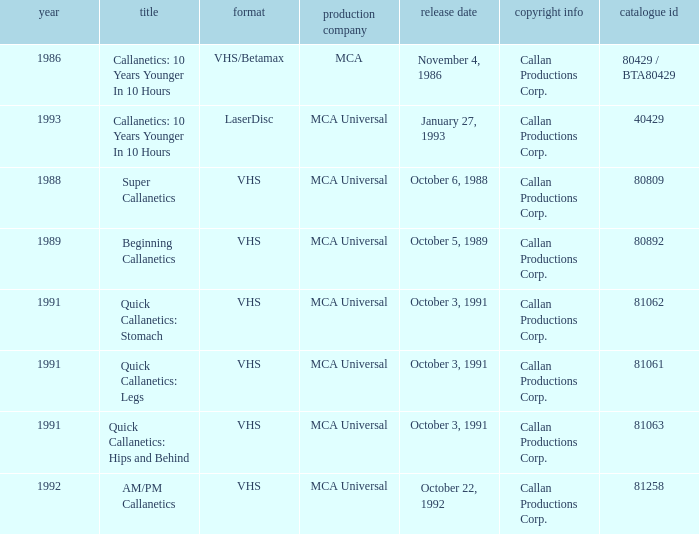Name the format for  quick callanetics: hips and behind VHS. 